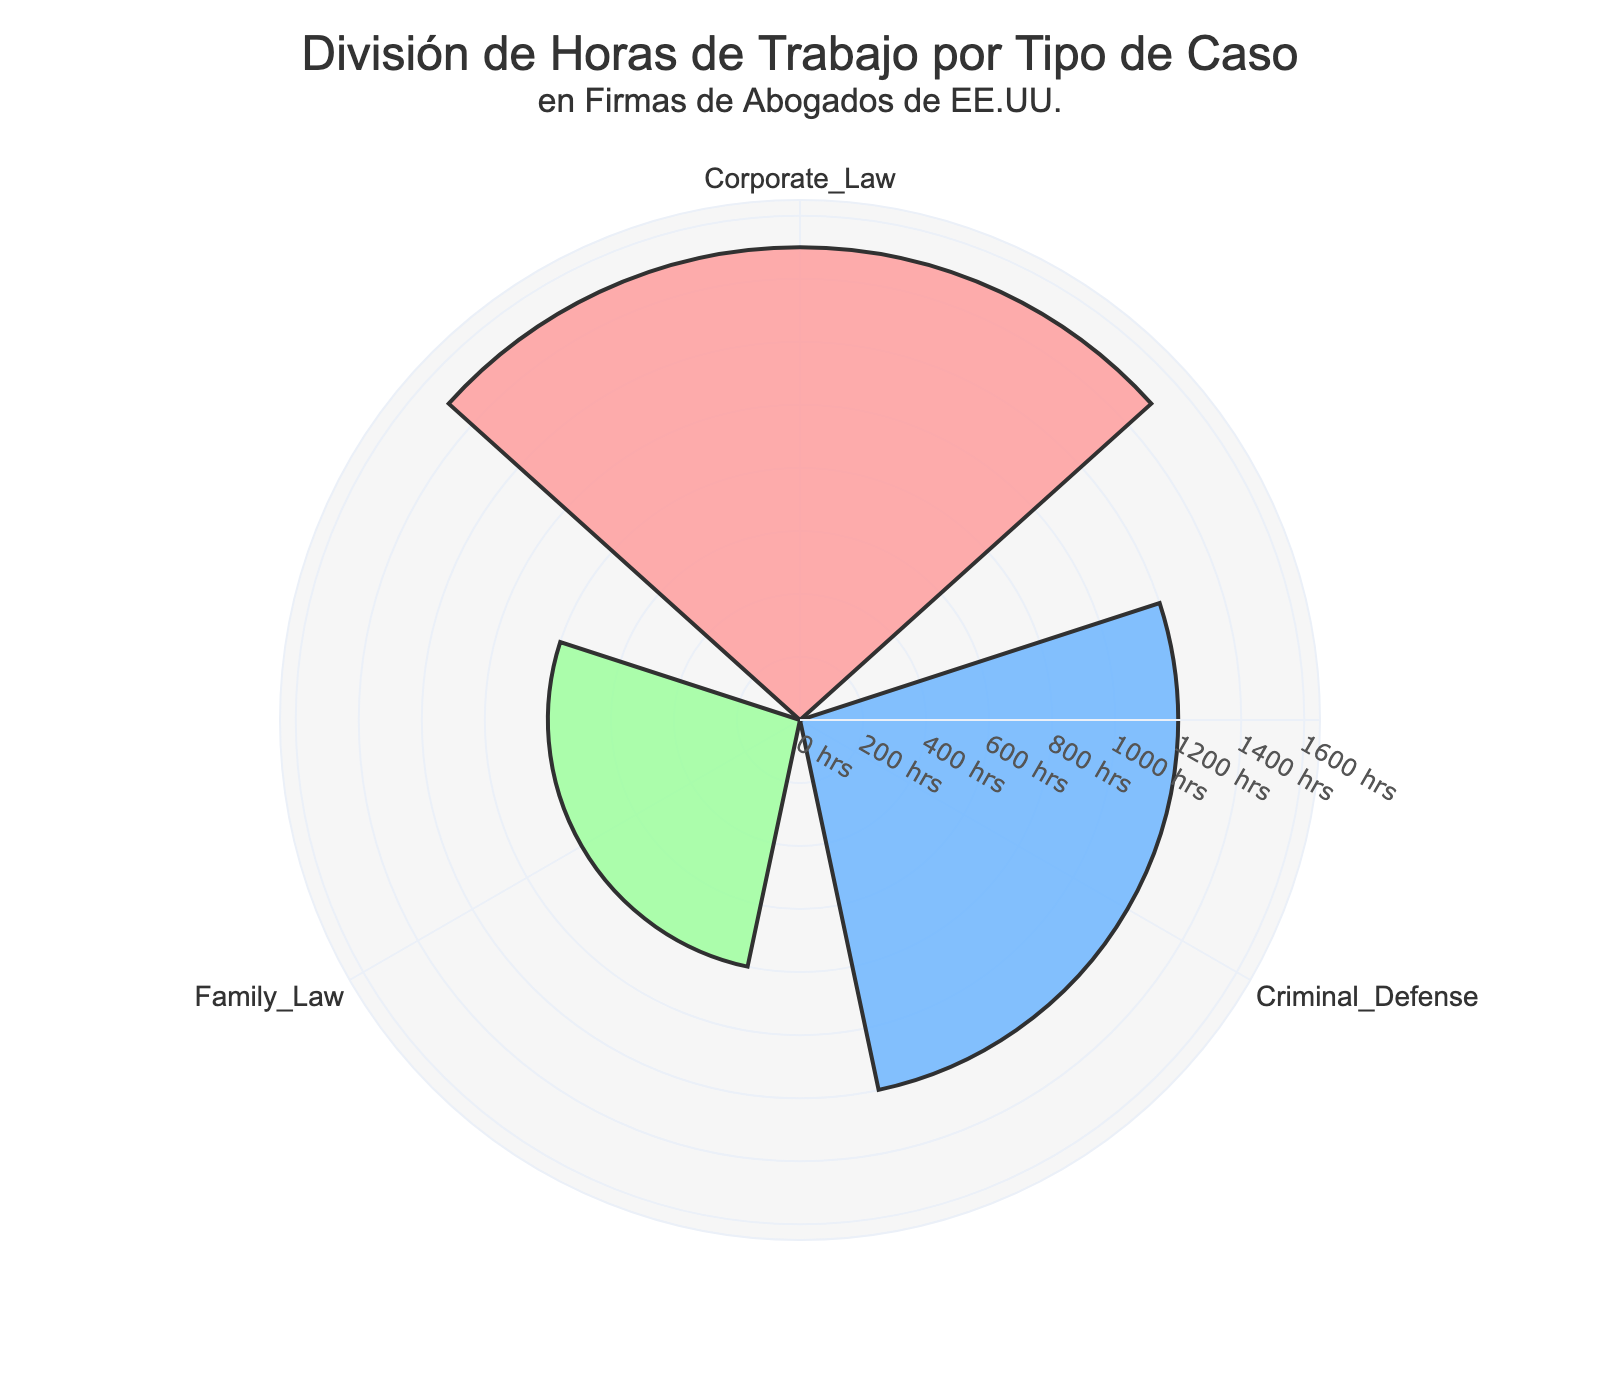What's the title of the chart? The title is positioned at the top and clearly states the main subject of the chart. It reads: "División de Horas de Trabajo por Tipo de Caso en Firmas de Abogados de EE.UU."
Answer: División de Horas de Trabajo por Tipo de Caso en Firmas de Abogados de EE.UU How many types of cases are represented in the chart? The chart displays three distinct types of cases, each represented by a bar in the rose chart.
Answer: 3 Which case type has the highest number of work hours? By comparing the lengths of the bars in the rose chart, the Corporate Law bar is the longest, indicating the highest number of work hours.
Answer: Corporate Law What is the difference in work hours between Corporate Law and Family Law? The work hours for Corporate Law and Family Law are 1500 and 800, respectively. The difference is calculated as 1500 - 800.
Answer: 700 What color is used to represent Criminal Defense? Criminal Defense is represented by a distinct light blue color in the rose chart.
Answer: Light blue Which case type has the fewest work hours? By observing the shortest bar in the rose chart, it is evident that Family Law has the fewest work hours.
Answer: Family Law What is the total number of work hours represented in the chart? Add the work hours of the three case types: Corporate Law (1500) + Criminal Defense (1200) + Family Law (800). The total is 3500 work hours.
Answer: 3500 How much less is the work hours of Criminal Defense compared to Corporate Law? Subtract the work hours of Criminal Defense (1200) from Corporate Law (1500): 1500 - 1200.
Answer: 300 Which case type’s work hours make up the second largest segment? By comparing the lengths of the bars in the rose chart, the second longest bar corresponds to Criminal Defense with 1200 work hours.
Answer: Criminal Defense Is the number of work hours for Family Law more or less than half of those for Corporate Law? Half of Corporate Law's hours is 1500 / 2 = 750. Family Law has 800 work hours, which is more than 750.
Answer: More 